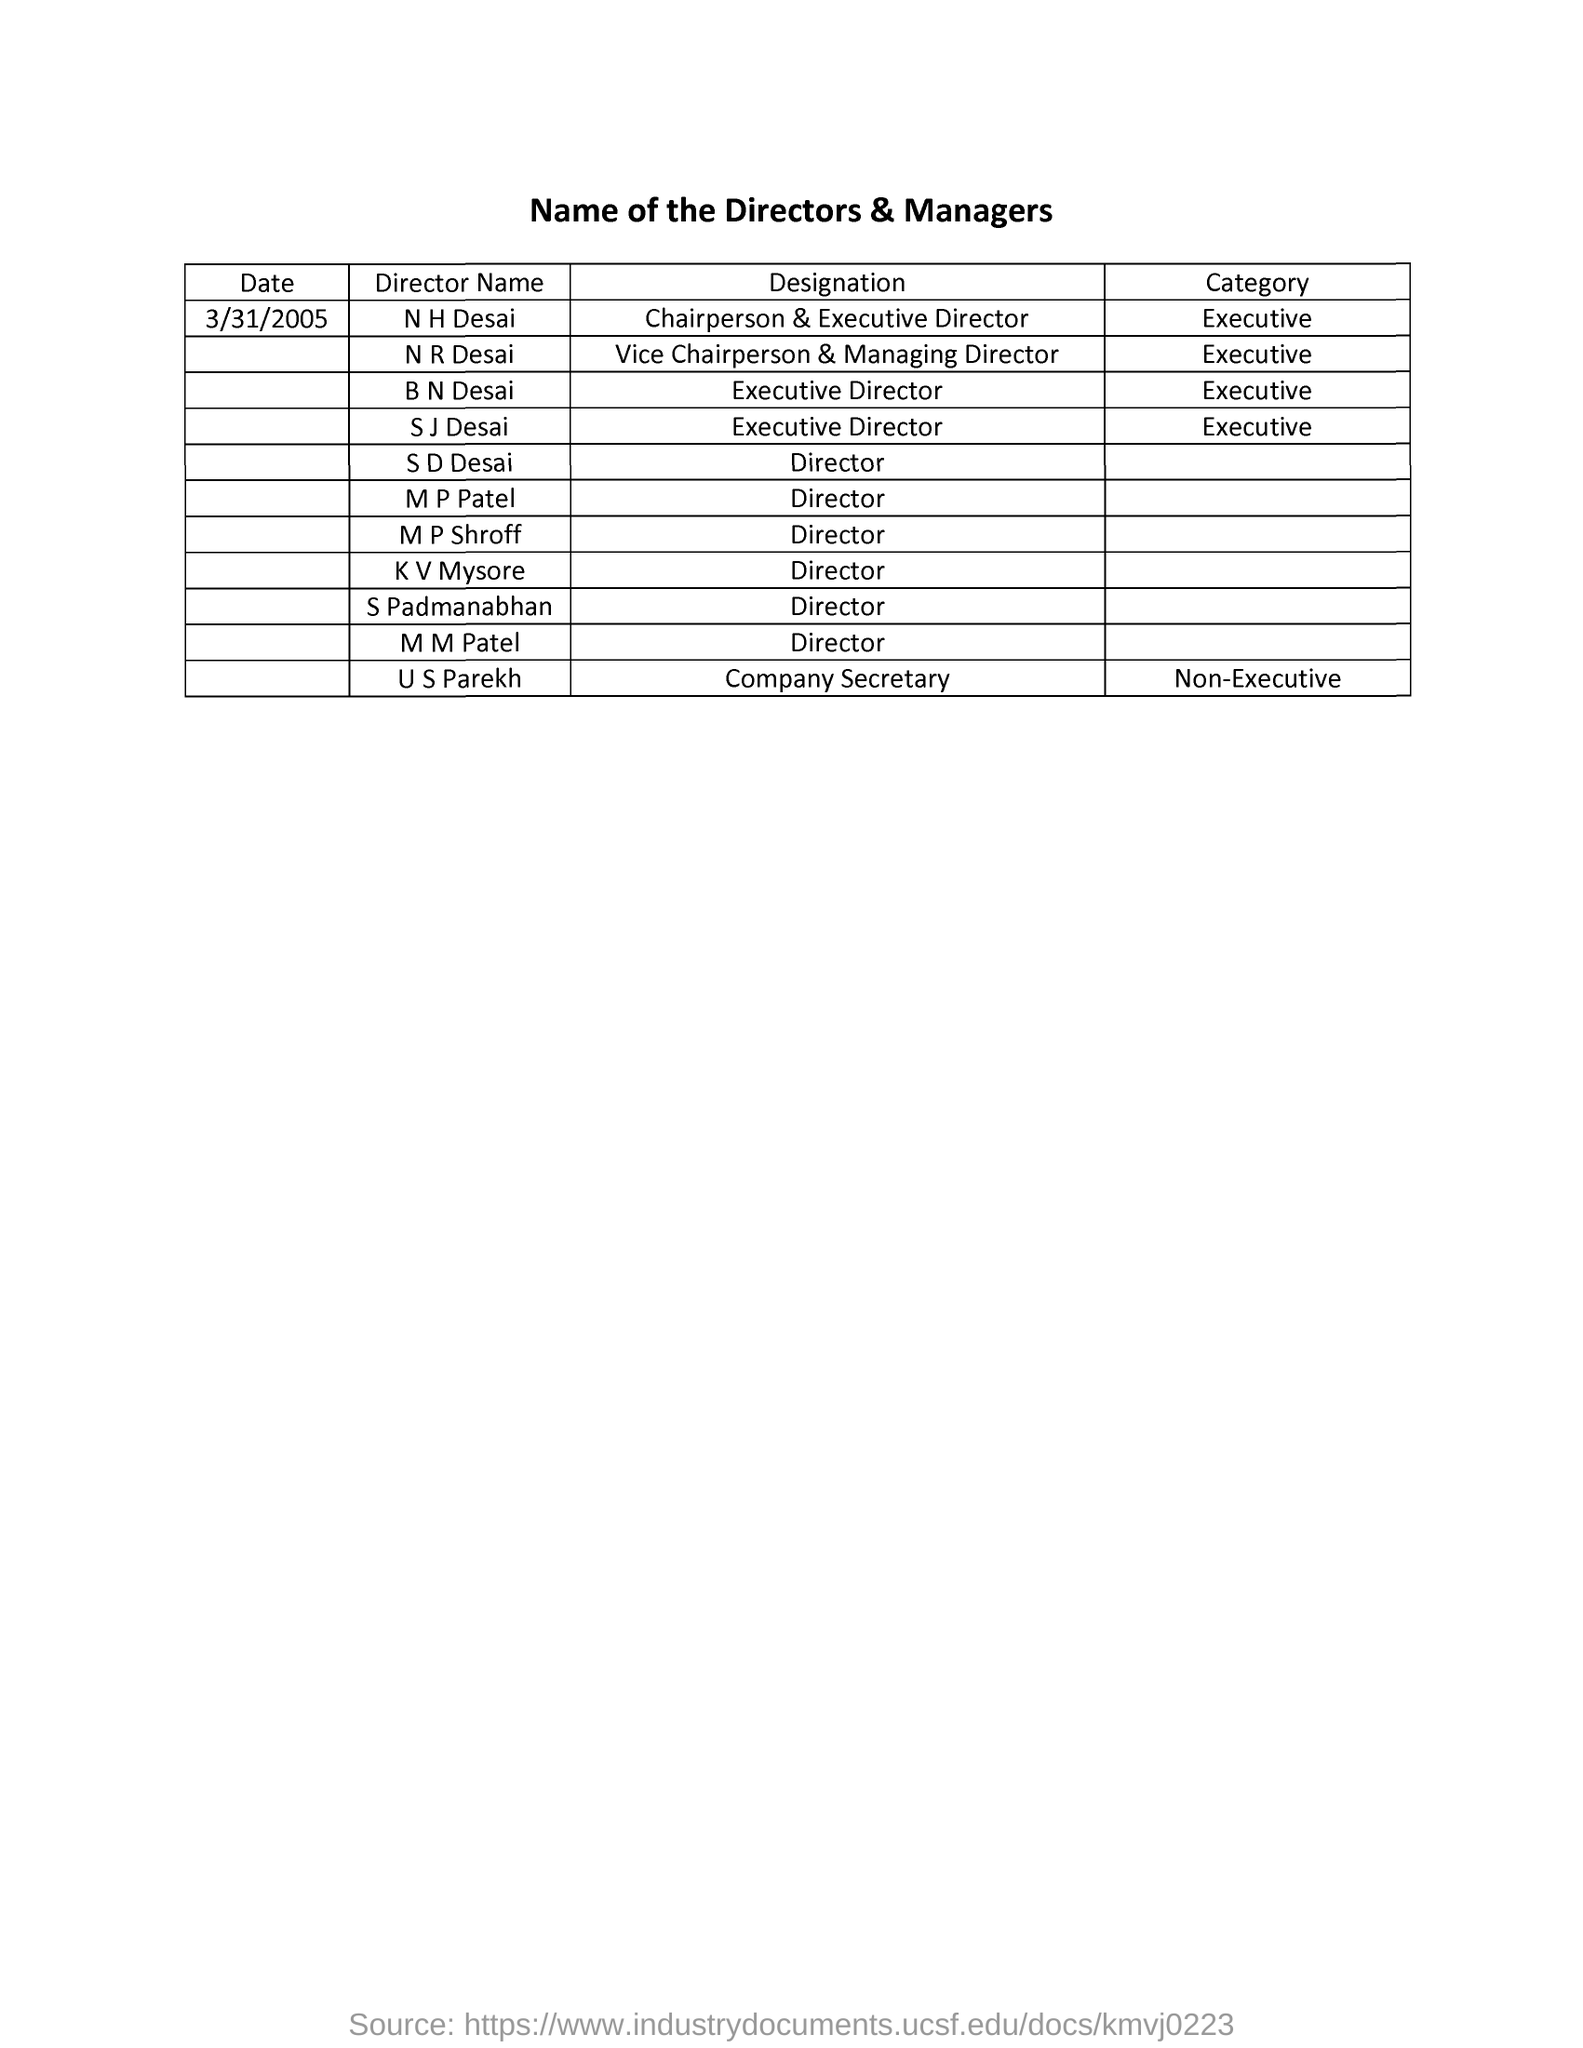Can you tell me more about the responsibilities of a Vice Chairperson & Managing Director? The role of a Vice Chairperson & Managing Director typically involves overseeing the daily operations of a company, making significant policy decisions, and assisting the Chairperson. They play a crucial role in setting strategic goals and ensuring company growth and stability. Their responsibilities also often include representing the company in major business negotiations and public engagements. 